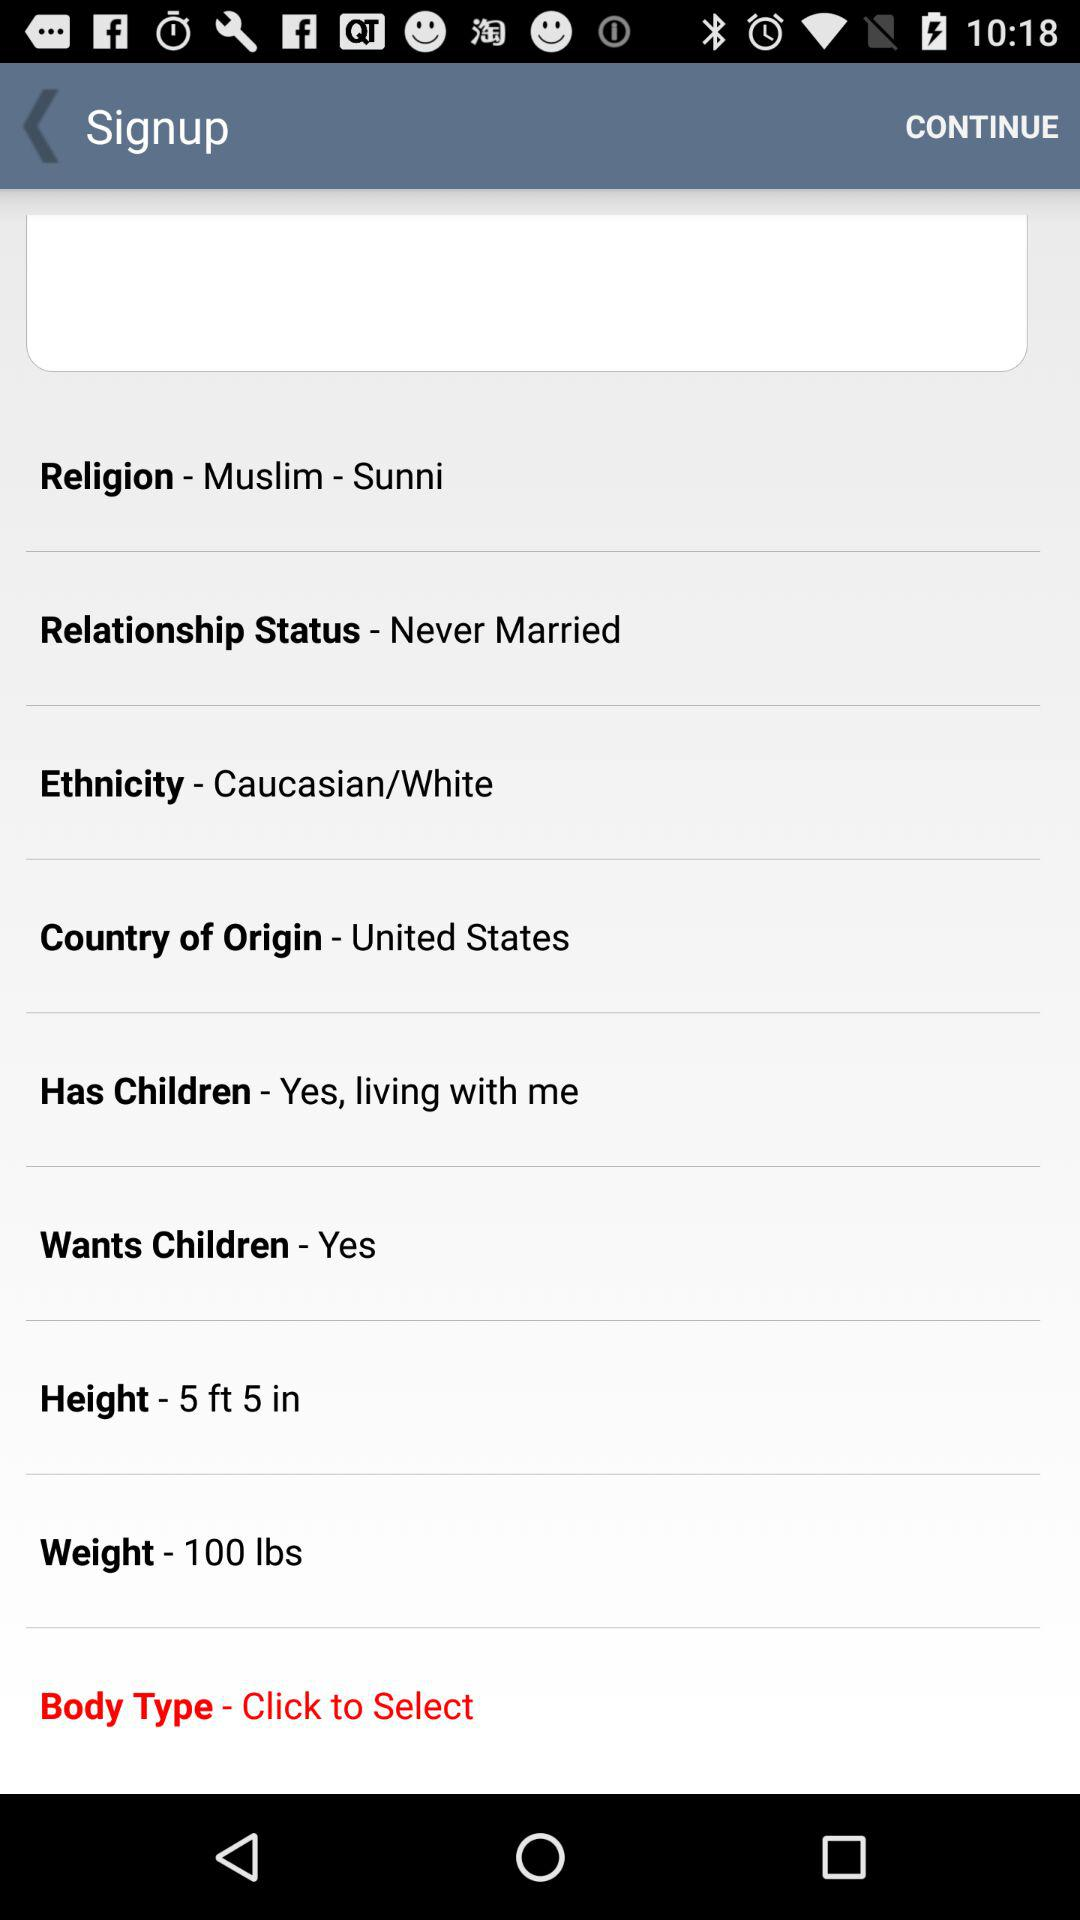What is the religion? The person is a Sunni Muslim. 